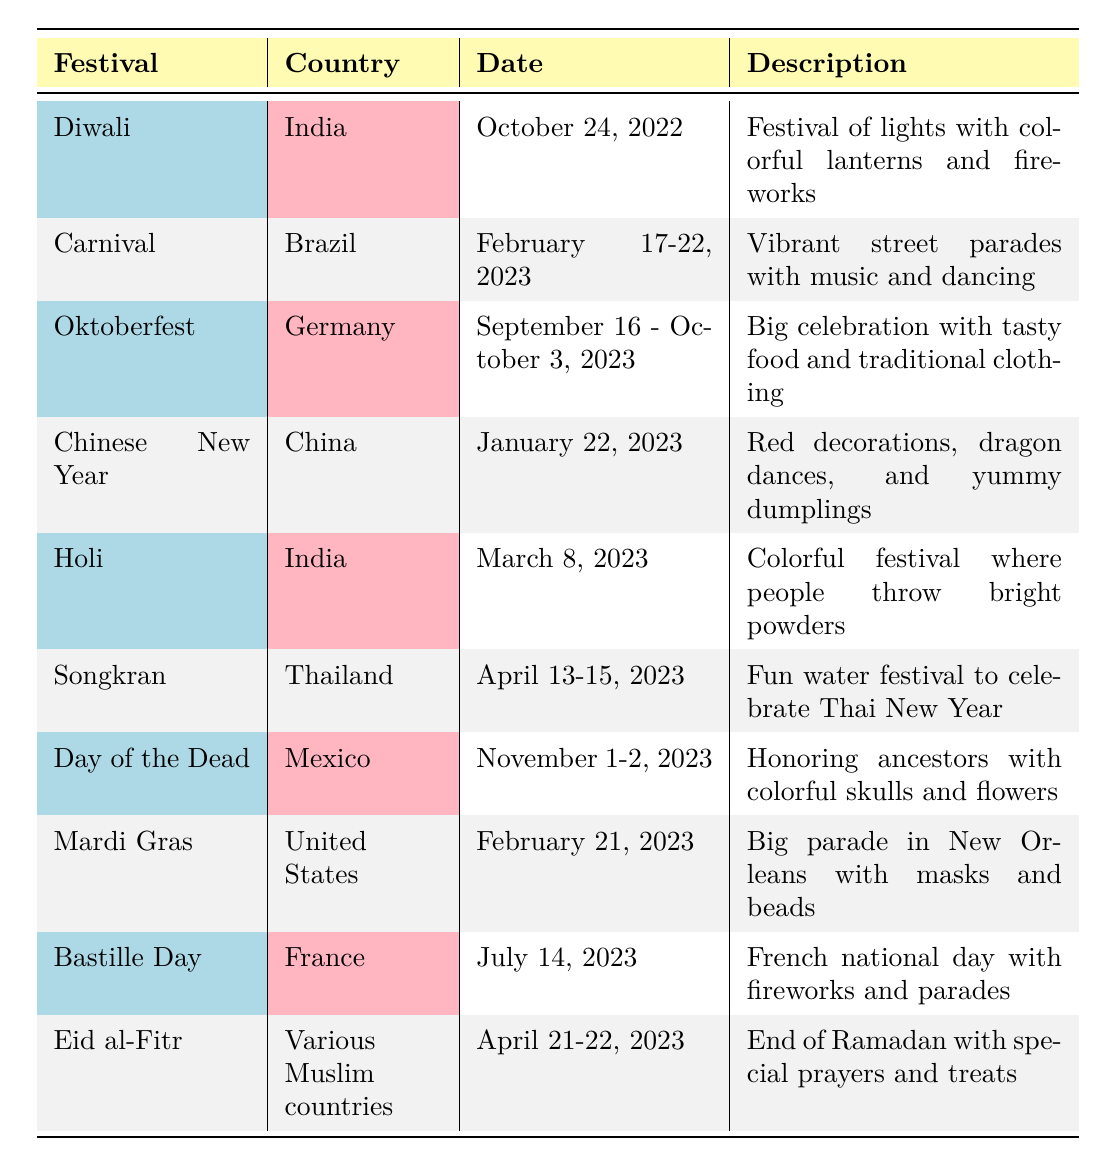What is the date of Diwali? The table lists Diwali under the festival column, and its corresponding date is provided in the date column as October 24, 2022.
Answer: October 24, 2022 Which festival takes place on February 21, 2023? By looking in the date column for February 21, 2023, we find it associated with Mardi Gras in the festival column.
Answer: Mardi Gras Is Oktoberfest celebrated in Brazil? The country listed next to Oktoberfest in the table is Germany, not Brazil, which answers the question as false.
Answer: No How many festivals occur in April? The table shows two festivals that have dates in April: Songkran (April 13-15) and Eid al-Fitr (April 21-22). Therefore, the count is 2.
Answer: 2 What is the description of Carnival? The description column next to Carnival provides details, stating it's a vibrant street parade with music and dancing.
Answer: Vibrant street parades with music and dancing Which festival is celebrated on July 14, 2023? The table indicates that the festival that occurs on July 14, 2023, is Bastille Day, as seen in the date column.
Answer: Bastille Day Are there more festivals in the table from India than from any other country? The table includes two festivals from India (Diwali and Holi), whereas other countries like Brazil, China, and Germany each have one or two festivals listed. Thus, India has the highest count with 2.
Answer: Yes What is the total number of days Carnival lasts? Carnival is listed with the dates February 17-22, 2023. To find the total days from February 17 to February 22, we calculate: 22 - 17 + 1 = 6 days.
Answer: 6 days Which two festivals are celebrated in January? Scanning the table, we see that the only festival celebrated in January is Chinese New Year on January 22, 2023. Thus, there is only one.
Answer: 1 festival Which festival has the most elaborate description? Looking closely at the descriptions, the festival with the most detailed description appears to be Day of the Dead with "Honoring ancestors with colorful skulls and flowers," as it provides cultural context.
Answer: Day of the Dead 